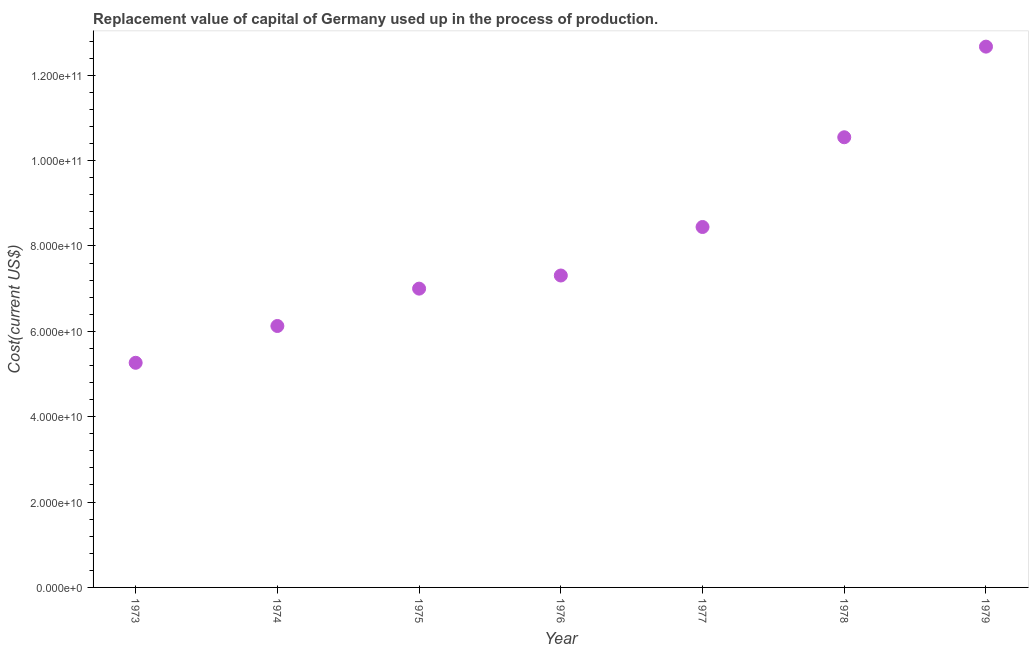What is the consumption of fixed capital in 1976?
Give a very brief answer. 7.31e+1. Across all years, what is the maximum consumption of fixed capital?
Offer a terse response. 1.27e+11. Across all years, what is the minimum consumption of fixed capital?
Ensure brevity in your answer.  5.26e+1. In which year was the consumption of fixed capital maximum?
Provide a short and direct response. 1979. What is the sum of the consumption of fixed capital?
Your answer should be very brief. 5.74e+11. What is the difference between the consumption of fixed capital in 1973 and 1979?
Your response must be concise. -7.41e+1. What is the average consumption of fixed capital per year?
Offer a very short reply. 8.19e+1. What is the median consumption of fixed capital?
Provide a short and direct response. 7.31e+1. In how many years, is the consumption of fixed capital greater than 20000000000 US$?
Give a very brief answer. 7. Do a majority of the years between 1975 and 1979 (inclusive) have consumption of fixed capital greater than 32000000000 US$?
Your answer should be very brief. Yes. What is the ratio of the consumption of fixed capital in 1975 to that in 1978?
Provide a short and direct response. 0.66. Is the consumption of fixed capital in 1978 less than that in 1979?
Offer a very short reply. Yes. Is the difference between the consumption of fixed capital in 1974 and 1978 greater than the difference between any two years?
Ensure brevity in your answer.  No. What is the difference between the highest and the second highest consumption of fixed capital?
Offer a very short reply. 2.12e+1. What is the difference between the highest and the lowest consumption of fixed capital?
Make the answer very short. 7.41e+1. What is the difference between two consecutive major ticks on the Y-axis?
Keep it short and to the point. 2.00e+1. Does the graph contain grids?
Your response must be concise. No. What is the title of the graph?
Provide a short and direct response. Replacement value of capital of Germany used up in the process of production. What is the label or title of the Y-axis?
Keep it short and to the point. Cost(current US$). What is the Cost(current US$) in 1973?
Provide a succinct answer. 5.26e+1. What is the Cost(current US$) in 1974?
Give a very brief answer. 6.12e+1. What is the Cost(current US$) in 1975?
Keep it short and to the point. 7.00e+1. What is the Cost(current US$) in 1976?
Your answer should be very brief. 7.31e+1. What is the Cost(current US$) in 1977?
Offer a very short reply. 8.44e+1. What is the Cost(current US$) in 1978?
Keep it short and to the point. 1.05e+11. What is the Cost(current US$) in 1979?
Make the answer very short. 1.27e+11. What is the difference between the Cost(current US$) in 1973 and 1974?
Give a very brief answer. -8.62e+09. What is the difference between the Cost(current US$) in 1973 and 1975?
Provide a short and direct response. -1.74e+1. What is the difference between the Cost(current US$) in 1973 and 1976?
Provide a short and direct response. -2.04e+1. What is the difference between the Cost(current US$) in 1973 and 1977?
Provide a short and direct response. -3.18e+1. What is the difference between the Cost(current US$) in 1973 and 1978?
Provide a short and direct response. -5.28e+1. What is the difference between the Cost(current US$) in 1973 and 1979?
Give a very brief answer. -7.41e+1. What is the difference between the Cost(current US$) in 1974 and 1975?
Provide a succinct answer. -8.75e+09. What is the difference between the Cost(current US$) in 1974 and 1976?
Keep it short and to the point. -1.18e+1. What is the difference between the Cost(current US$) in 1974 and 1977?
Provide a short and direct response. -2.32e+1. What is the difference between the Cost(current US$) in 1974 and 1978?
Provide a short and direct response. -4.42e+1. What is the difference between the Cost(current US$) in 1974 and 1979?
Your answer should be compact. -6.54e+1. What is the difference between the Cost(current US$) in 1975 and 1976?
Offer a very short reply. -3.08e+09. What is the difference between the Cost(current US$) in 1975 and 1977?
Provide a succinct answer. -1.44e+1. What is the difference between the Cost(current US$) in 1975 and 1978?
Offer a very short reply. -3.55e+1. What is the difference between the Cost(current US$) in 1975 and 1979?
Ensure brevity in your answer.  -5.67e+1. What is the difference between the Cost(current US$) in 1976 and 1977?
Offer a very short reply. -1.14e+1. What is the difference between the Cost(current US$) in 1976 and 1978?
Your answer should be compact. -3.24e+1. What is the difference between the Cost(current US$) in 1976 and 1979?
Offer a very short reply. -5.36e+1. What is the difference between the Cost(current US$) in 1977 and 1978?
Ensure brevity in your answer.  -2.10e+1. What is the difference between the Cost(current US$) in 1977 and 1979?
Ensure brevity in your answer.  -4.23e+1. What is the difference between the Cost(current US$) in 1978 and 1979?
Provide a short and direct response. -2.12e+1. What is the ratio of the Cost(current US$) in 1973 to that in 1974?
Give a very brief answer. 0.86. What is the ratio of the Cost(current US$) in 1973 to that in 1975?
Offer a terse response. 0.75. What is the ratio of the Cost(current US$) in 1973 to that in 1976?
Your answer should be compact. 0.72. What is the ratio of the Cost(current US$) in 1973 to that in 1977?
Keep it short and to the point. 0.62. What is the ratio of the Cost(current US$) in 1973 to that in 1978?
Provide a short and direct response. 0.5. What is the ratio of the Cost(current US$) in 1973 to that in 1979?
Offer a very short reply. 0.41. What is the ratio of the Cost(current US$) in 1974 to that in 1975?
Make the answer very short. 0.88. What is the ratio of the Cost(current US$) in 1974 to that in 1976?
Offer a terse response. 0.84. What is the ratio of the Cost(current US$) in 1974 to that in 1977?
Keep it short and to the point. 0.72. What is the ratio of the Cost(current US$) in 1974 to that in 1978?
Your answer should be very brief. 0.58. What is the ratio of the Cost(current US$) in 1974 to that in 1979?
Provide a succinct answer. 0.48. What is the ratio of the Cost(current US$) in 1975 to that in 1976?
Offer a terse response. 0.96. What is the ratio of the Cost(current US$) in 1975 to that in 1977?
Ensure brevity in your answer.  0.83. What is the ratio of the Cost(current US$) in 1975 to that in 1978?
Ensure brevity in your answer.  0.66. What is the ratio of the Cost(current US$) in 1975 to that in 1979?
Your answer should be very brief. 0.55. What is the ratio of the Cost(current US$) in 1976 to that in 1977?
Keep it short and to the point. 0.86. What is the ratio of the Cost(current US$) in 1976 to that in 1978?
Make the answer very short. 0.69. What is the ratio of the Cost(current US$) in 1976 to that in 1979?
Ensure brevity in your answer.  0.58. What is the ratio of the Cost(current US$) in 1977 to that in 1978?
Your answer should be compact. 0.8. What is the ratio of the Cost(current US$) in 1977 to that in 1979?
Make the answer very short. 0.67. What is the ratio of the Cost(current US$) in 1978 to that in 1979?
Keep it short and to the point. 0.83. 